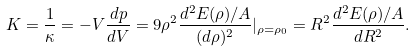<formula> <loc_0><loc_0><loc_500><loc_500>K = \frac { 1 } { \kappa } = - V \frac { d p } { d V } = 9 \rho ^ { 2 } \frac { d ^ { 2 } E ( \rho ) / A } { ( d \rho ) ^ { 2 } } | _ { \rho = \rho _ { 0 } } = R ^ { 2 } \frac { d ^ { 2 } E ( \rho ) / A } { d R ^ { 2 } } .</formula> 